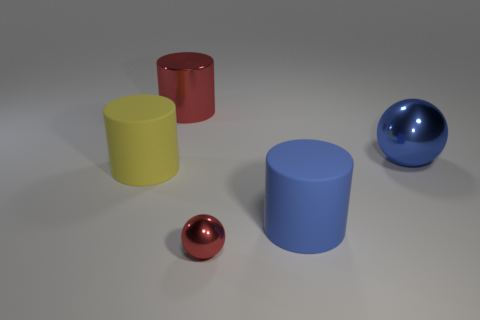Is the color of the small metal sphere the same as the metallic cylinder?
Make the answer very short. Yes. There is a matte object that is on the left side of the red shiny cylinder; is its size the same as the large red cylinder?
Offer a terse response. Yes. How many other objects are the same shape as the big red thing?
Your answer should be compact. 2. How many yellow things are big metal spheres or big matte cylinders?
Give a very brief answer. 1. There is a shiny thing in front of the yellow matte cylinder; is its color the same as the shiny cylinder?
Provide a succinct answer. Yes. There is a yellow thing that is the same material as the big blue cylinder; what shape is it?
Your answer should be compact. Cylinder. What color is the cylinder that is both right of the large yellow cylinder and in front of the big red shiny cylinder?
Ensure brevity in your answer.  Blue. There is a yellow rubber object to the left of the shiny object to the right of the blue cylinder; how big is it?
Make the answer very short. Large. Is there a big thing that has the same color as the small thing?
Provide a short and direct response. Yes. Is the number of large matte things that are behind the large yellow thing the same as the number of large yellow objects?
Offer a terse response. No. 